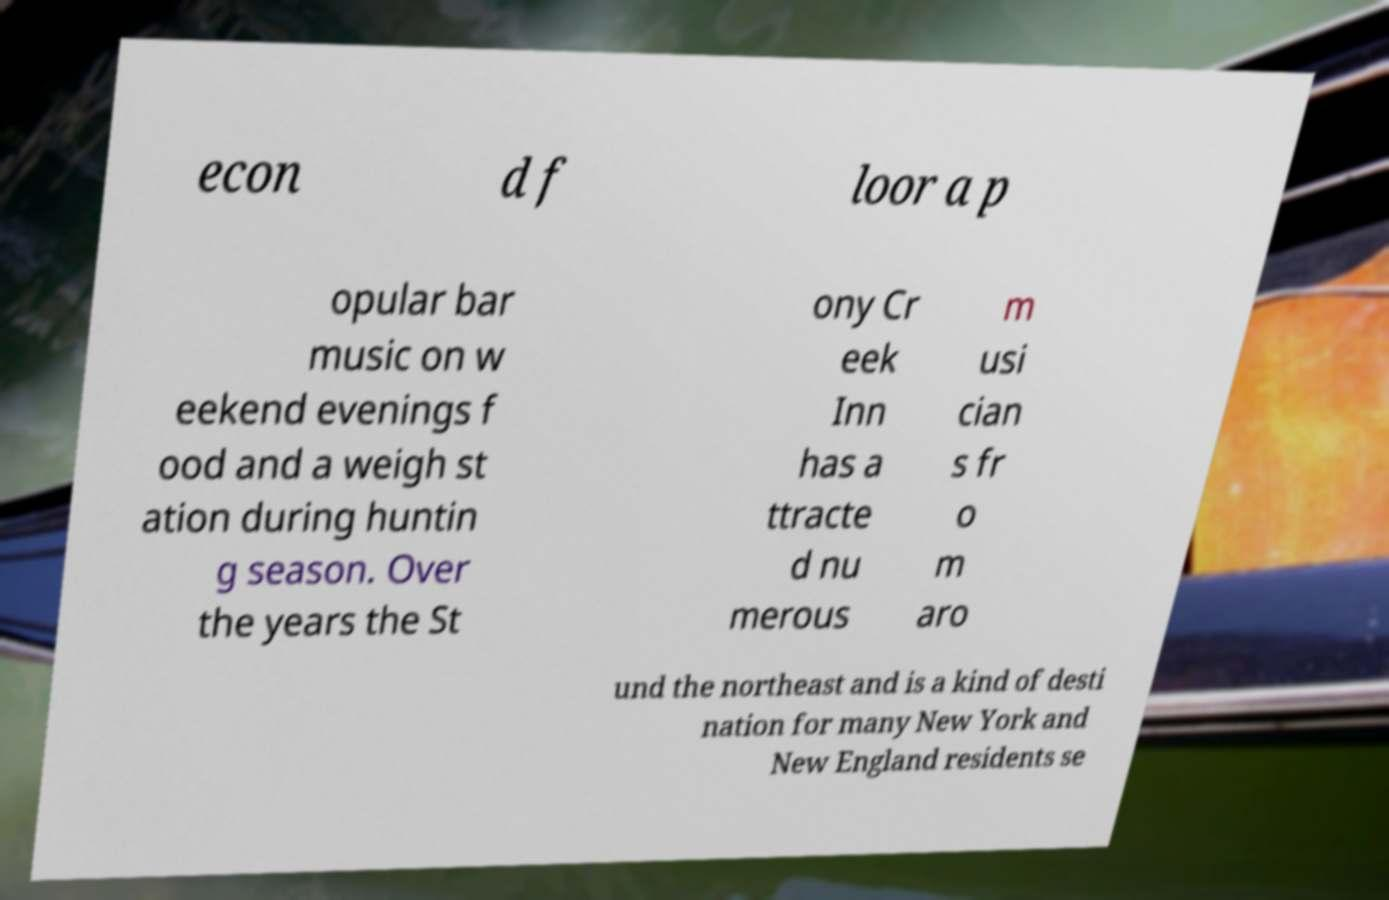I need the written content from this picture converted into text. Can you do that? econ d f loor a p opular bar music on w eekend evenings f ood and a weigh st ation during huntin g season. Over the years the St ony Cr eek Inn has a ttracte d nu merous m usi cian s fr o m aro und the northeast and is a kind of desti nation for many New York and New England residents se 